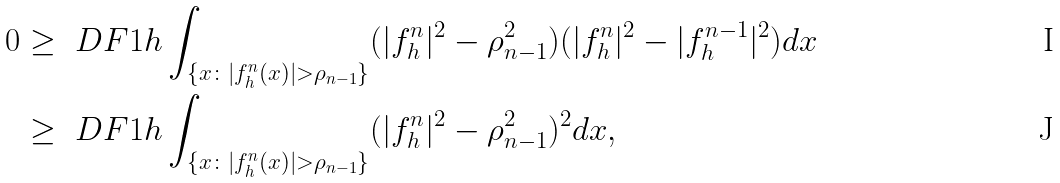Convert formula to latex. <formula><loc_0><loc_0><loc_500><loc_500>0 & \geq \ D F { 1 } { h } \int _ { \{ x \colon | f _ { h } ^ { n } ( x ) | > \rho _ { n - 1 } \} } ( | f _ { h } ^ { n } | ^ { 2 } - \rho _ { n - 1 } ^ { 2 } ) ( | f _ { h } ^ { n } | ^ { 2 } - | f _ { h } ^ { n - 1 } | ^ { 2 } ) d x \\ & \geq \ D F { 1 } { h } \int _ { \{ x \colon | f _ { h } ^ { n } ( x ) | > \rho _ { n - 1 } \} } ( | f _ { h } ^ { n } | ^ { 2 } - \rho _ { n - 1 } ^ { 2 } ) ^ { 2 } d x ,</formula> 